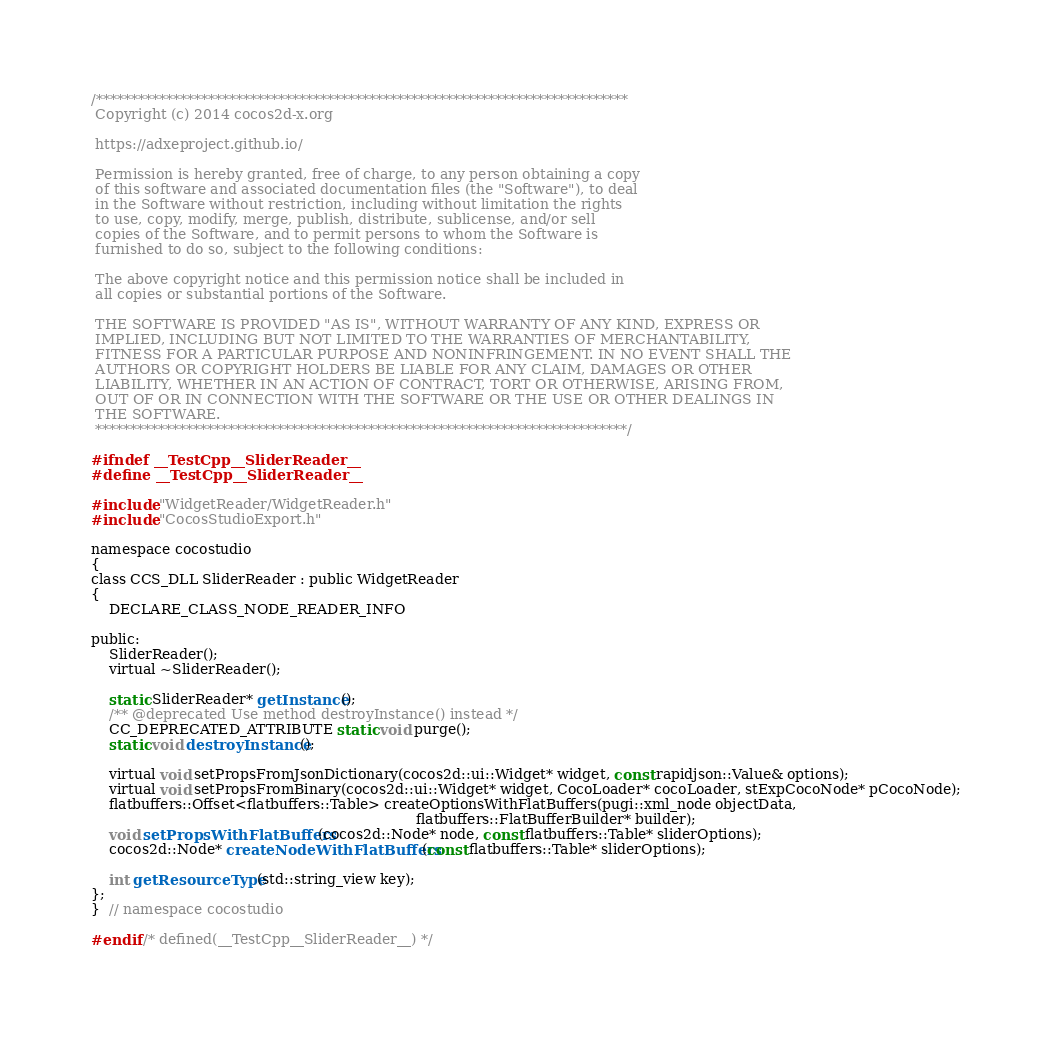Convert code to text. <code><loc_0><loc_0><loc_500><loc_500><_C_>/****************************************************************************
 Copyright (c) 2014 cocos2d-x.org

 https://adxeproject.github.io/

 Permission is hereby granted, free of charge, to any person obtaining a copy
 of this software and associated documentation files (the "Software"), to deal
 in the Software without restriction, including without limitation the rights
 to use, copy, modify, merge, publish, distribute, sublicense, and/or sell
 copies of the Software, and to permit persons to whom the Software is
 furnished to do so, subject to the following conditions:

 The above copyright notice and this permission notice shall be included in
 all copies or substantial portions of the Software.

 THE SOFTWARE IS PROVIDED "AS IS", WITHOUT WARRANTY OF ANY KIND, EXPRESS OR
 IMPLIED, INCLUDING BUT NOT LIMITED TO THE WARRANTIES OF MERCHANTABILITY,
 FITNESS FOR A PARTICULAR PURPOSE AND NONINFRINGEMENT. IN NO EVENT SHALL THE
 AUTHORS OR COPYRIGHT HOLDERS BE LIABLE FOR ANY CLAIM, DAMAGES OR OTHER
 LIABILITY, WHETHER IN AN ACTION OF CONTRACT, TORT OR OTHERWISE, ARISING FROM,
 OUT OF OR IN CONNECTION WITH THE SOFTWARE OR THE USE OR OTHER DEALINGS IN
 THE SOFTWARE.
 ****************************************************************************/

#ifndef __TestCpp__SliderReader__
#define __TestCpp__SliderReader__

#include "WidgetReader/WidgetReader.h"
#include "CocosStudioExport.h"

namespace cocostudio
{
class CCS_DLL SliderReader : public WidgetReader
{
    DECLARE_CLASS_NODE_READER_INFO

public:
    SliderReader();
    virtual ~SliderReader();

    static SliderReader* getInstance();
    /** @deprecated Use method destroyInstance() instead */
    CC_DEPRECATED_ATTRIBUTE static void purge();
    static void destroyInstance();

    virtual void setPropsFromJsonDictionary(cocos2d::ui::Widget* widget, const rapidjson::Value& options);
    virtual void setPropsFromBinary(cocos2d::ui::Widget* widget, CocoLoader* cocoLoader, stExpCocoNode* pCocoNode);
    flatbuffers::Offset<flatbuffers::Table> createOptionsWithFlatBuffers(pugi::xml_node objectData,
                                                                         flatbuffers::FlatBufferBuilder* builder);
    void setPropsWithFlatBuffers(cocos2d::Node* node, const flatbuffers::Table* sliderOptions);
    cocos2d::Node* createNodeWithFlatBuffers(const flatbuffers::Table* sliderOptions);

    int getResourceType(std::string_view key);
};
}  // namespace cocostudio

#endif /* defined(__TestCpp__SliderReader__) */
</code> 